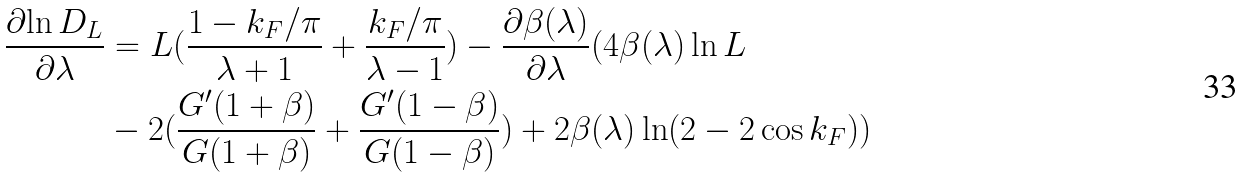Convert formula to latex. <formula><loc_0><loc_0><loc_500><loc_500>\frac { \partial { \ln D _ { L } } } { \partial { \lambda } } & = L ( \frac { 1 - k _ { F } / \pi } { \lambda + 1 } + \frac { k _ { F } / \pi } { \lambda - 1 } ) - \frac { \partial { \beta ( \lambda ) } } { \partial { \lambda } } ( 4 \beta ( \lambda ) \ln L \\ & - 2 ( \frac { G ^ { \prime } ( 1 + \beta ) } { G ( 1 + \beta ) } + \frac { G ^ { \prime } ( 1 - \beta ) } { G ( 1 - \beta ) } ) + 2 \beta ( \lambda ) \ln ( 2 - 2 \cos k _ { F } ) ) \\</formula> 